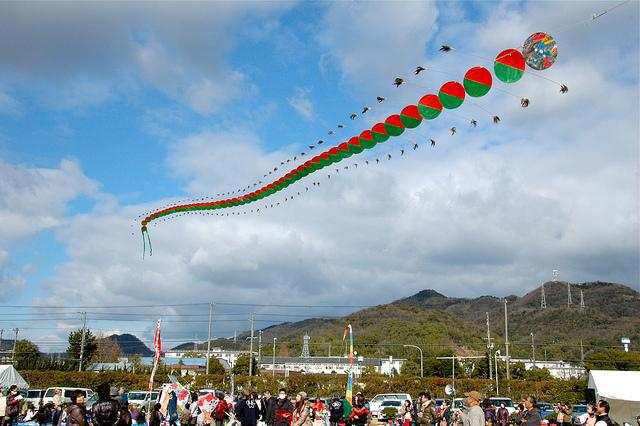Which one of these countries has a flag that is most similar to the kite? Please explain your reasoning. bangladesh. Bangladesh is a country with a red and green flag. 